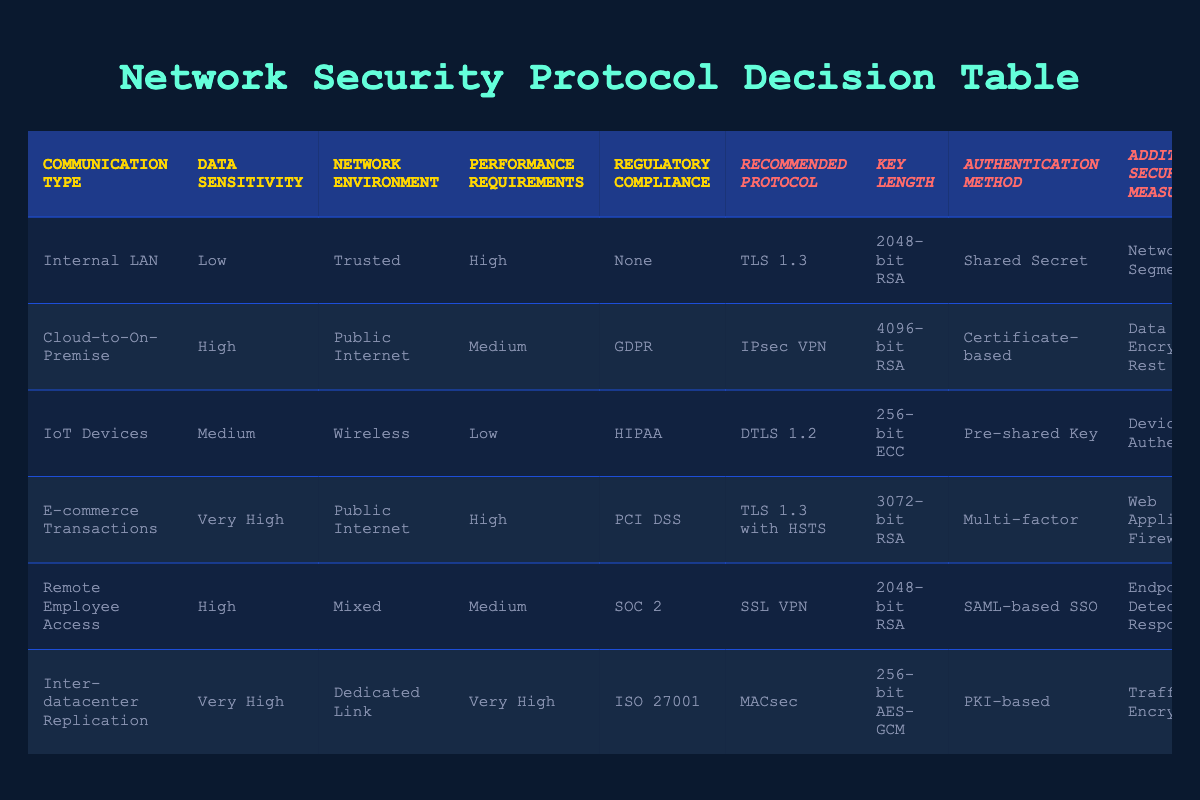What is the recommended protocol for E-commerce Transactions? The table indicates that the recommended protocol for E-commerce Transactions is "TLS 1.3 with HSTS." This is found by locating the row corresponding to E-commerce Transactions and reading the Recommended Protocol column.
Answer: TLS 1.3 with HSTS What is the key length for Cloud-to-On-Premise communication? In the table, the key length for Cloud-to-On-Premise communication is "4096-bit RSA." This is obtained by identifying the row for Cloud-to-On-Premise and checking the Key Length column.
Answer: 4096-bit RSA Is the recommended authentication method for IoT Devices a password? The table shows that the recommended authentication method for IoT Devices is "Pre-shared Key," which is not a typical password-based method. Therefore, the response to the question is no.
Answer: No Which communication type requires the highest performance requirements? The performance requirements of each communication type can be reviewed from the table. "Inter-datacenter Replication" has "Very High" performance requirements, which stands out from the rest. This is verified by looking for the highest entry in the Performance Requirements column.
Answer: Inter-datacenter Replication How many different recommended protocols are listed in the table? To find the total number of unique recommended protocols, we look at the Recommended Protocol column and count the distinct entries. The table lists six different recommended protocols (TLS 1.3, IPsec VPN, DTLS 1.2, TLS 1.3 with HSTS, SSL VPN, MACsec). This gives a total count of 6.
Answer: 6 What combination of data sensitivity and network environment is associated with the SSL VPN protocol? The SSL VPN protocol is linked to "High" data sensitivity and a "Mixed" network environment, as evidenced by examining the row that details the SSL VPN in the Recommended Protocol column. This is confirmed by reading the corresponding values in the Data Sensitivity and Network Environment columns.
Answer: High, Mixed Does the communication type 'Internal LAN' have any regulatory compliance requirements? According to the table, the Internal LAN communication type has "None" listed under Regulatory Compliance. This indicates that there are no regulatory requirements associated with it, leading to a response of no.
Answer: No What additional security measures are recommended for Remote Employee Access? The additional security measures for Remote Employee Access are described in the table as "Endpoint Detection and Response." This is identifiable by locating the Remote Employee Access row and noting the Additional Security Measures column's entry.
Answer: Endpoint Detection and Response 